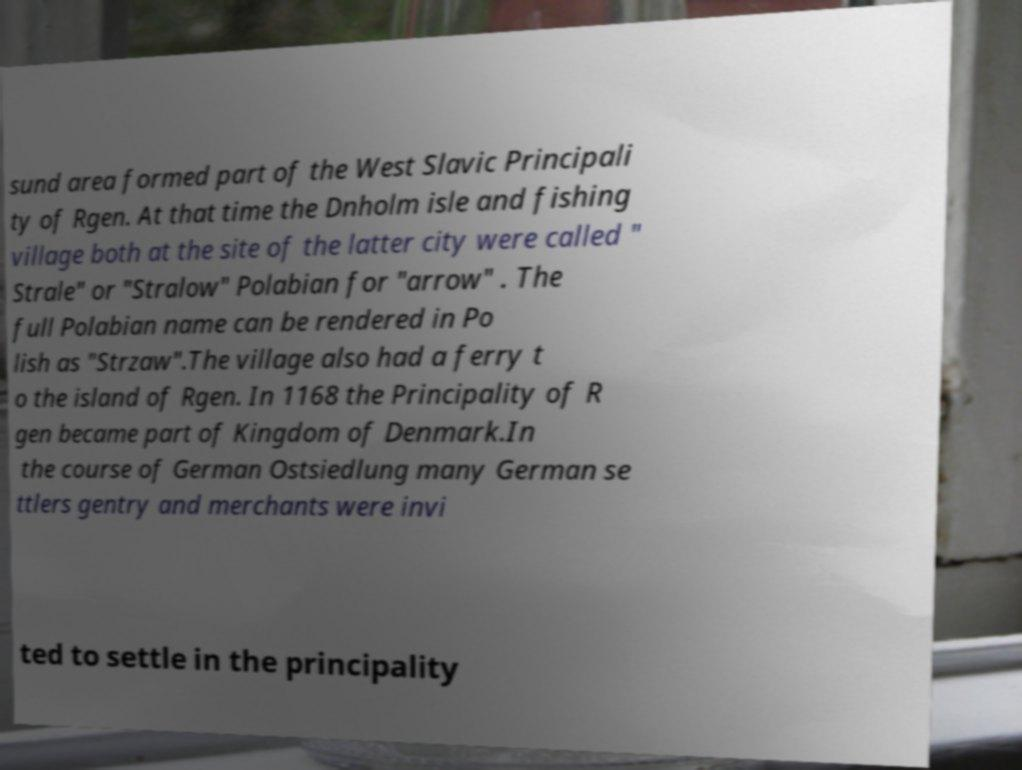Please identify and transcribe the text found in this image. sund area formed part of the West Slavic Principali ty of Rgen. At that time the Dnholm isle and fishing village both at the site of the latter city were called " Strale" or "Stralow" Polabian for "arrow" . The full Polabian name can be rendered in Po lish as "Strzaw".The village also had a ferry t o the island of Rgen. In 1168 the Principality of R gen became part of Kingdom of Denmark.In the course of German Ostsiedlung many German se ttlers gentry and merchants were invi ted to settle in the principality 